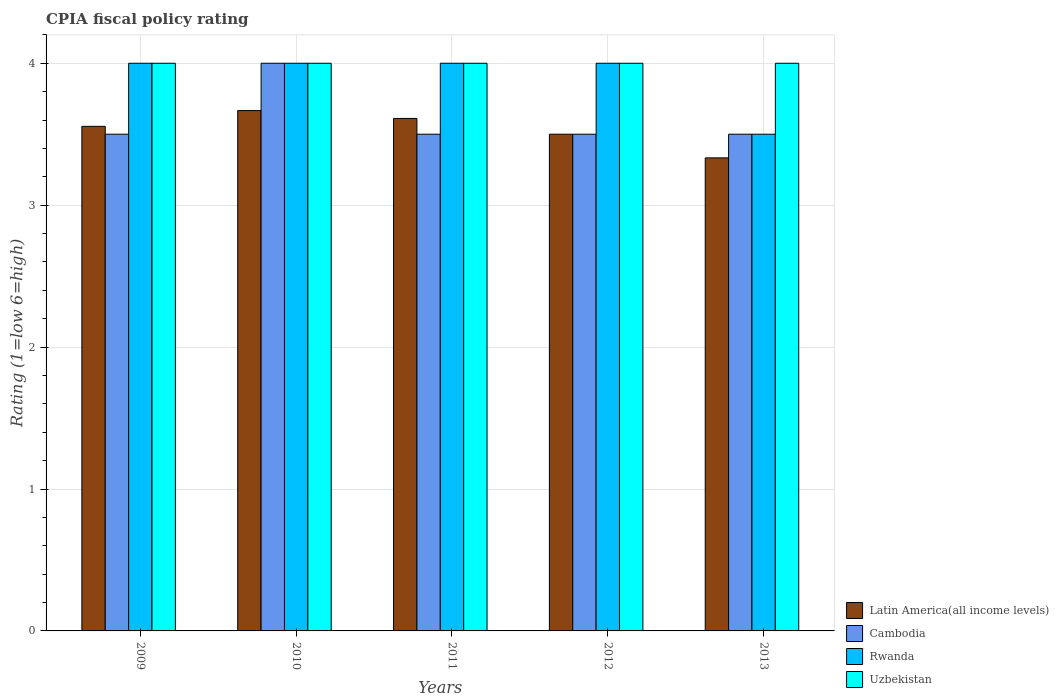Are the number of bars per tick equal to the number of legend labels?
Provide a succinct answer. Yes. Are the number of bars on each tick of the X-axis equal?
Ensure brevity in your answer.  Yes. How many bars are there on the 4th tick from the left?
Ensure brevity in your answer.  4. How many bars are there on the 2nd tick from the right?
Ensure brevity in your answer.  4. What is the CPIA rating in Cambodia in 2011?
Offer a terse response. 3.5. Across all years, what is the minimum CPIA rating in Rwanda?
Your answer should be compact. 3.5. In which year was the CPIA rating in Uzbekistan minimum?
Your answer should be very brief. 2009. What is the total CPIA rating in Latin America(all income levels) in the graph?
Provide a succinct answer. 17.67. What is the difference between the CPIA rating in Uzbekistan in 2010 and that in 2013?
Your answer should be very brief. 0. What is the difference between the CPIA rating in Uzbekistan in 2010 and the CPIA rating in Rwanda in 2012?
Your answer should be very brief. 0. What is the average CPIA rating in Rwanda per year?
Your answer should be compact. 3.9. In the year 2012, what is the difference between the CPIA rating in Latin America(all income levels) and CPIA rating in Rwanda?
Offer a terse response. -0.5. In how many years, is the CPIA rating in Uzbekistan greater than 4?
Provide a succinct answer. 0. What is the ratio of the CPIA rating in Rwanda in 2010 to that in 2013?
Provide a succinct answer. 1.14. Is the CPIA rating in Cambodia in 2010 less than that in 2011?
Your response must be concise. No. What is the difference between the highest and the second highest CPIA rating in Cambodia?
Give a very brief answer. 0.5. In how many years, is the CPIA rating in Rwanda greater than the average CPIA rating in Rwanda taken over all years?
Keep it short and to the point. 4. Is it the case that in every year, the sum of the CPIA rating in Latin America(all income levels) and CPIA rating in Uzbekistan is greater than the sum of CPIA rating in Cambodia and CPIA rating in Rwanda?
Your answer should be compact. No. What does the 3rd bar from the left in 2009 represents?
Ensure brevity in your answer.  Rwanda. What does the 1st bar from the right in 2012 represents?
Your answer should be very brief. Uzbekistan. How many years are there in the graph?
Your answer should be very brief. 5. Does the graph contain any zero values?
Ensure brevity in your answer.  No. Where does the legend appear in the graph?
Offer a very short reply. Bottom right. How many legend labels are there?
Provide a succinct answer. 4. How are the legend labels stacked?
Your response must be concise. Vertical. What is the title of the graph?
Your answer should be very brief. CPIA fiscal policy rating. Does "Europe(developing only)" appear as one of the legend labels in the graph?
Ensure brevity in your answer.  No. What is the label or title of the X-axis?
Keep it short and to the point. Years. What is the Rating (1=low 6=high) in Latin America(all income levels) in 2009?
Provide a succinct answer. 3.56. What is the Rating (1=low 6=high) in Rwanda in 2009?
Provide a short and direct response. 4. What is the Rating (1=low 6=high) of Latin America(all income levels) in 2010?
Your response must be concise. 3.67. What is the Rating (1=low 6=high) in Cambodia in 2010?
Keep it short and to the point. 4. What is the Rating (1=low 6=high) of Latin America(all income levels) in 2011?
Keep it short and to the point. 3.61. What is the Rating (1=low 6=high) of Cambodia in 2011?
Keep it short and to the point. 3.5. What is the Rating (1=low 6=high) in Rwanda in 2011?
Provide a succinct answer. 4. What is the Rating (1=low 6=high) in Uzbekistan in 2011?
Offer a very short reply. 4. What is the Rating (1=low 6=high) of Rwanda in 2012?
Make the answer very short. 4. What is the Rating (1=low 6=high) in Latin America(all income levels) in 2013?
Provide a succinct answer. 3.33. What is the Rating (1=low 6=high) in Rwanda in 2013?
Keep it short and to the point. 3.5. Across all years, what is the maximum Rating (1=low 6=high) of Latin America(all income levels)?
Ensure brevity in your answer.  3.67. Across all years, what is the maximum Rating (1=low 6=high) in Cambodia?
Offer a terse response. 4. Across all years, what is the maximum Rating (1=low 6=high) in Rwanda?
Ensure brevity in your answer.  4. Across all years, what is the maximum Rating (1=low 6=high) in Uzbekistan?
Keep it short and to the point. 4. Across all years, what is the minimum Rating (1=low 6=high) of Latin America(all income levels)?
Offer a terse response. 3.33. What is the total Rating (1=low 6=high) of Latin America(all income levels) in the graph?
Provide a short and direct response. 17.67. What is the total Rating (1=low 6=high) of Uzbekistan in the graph?
Give a very brief answer. 20. What is the difference between the Rating (1=low 6=high) in Latin America(all income levels) in 2009 and that in 2010?
Offer a terse response. -0.11. What is the difference between the Rating (1=low 6=high) of Cambodia in 2009 and that in 2010?
Provide a succinct answer. -0.5. What is the difference between the Rating (1=low 6=high) in Latin America(all income levels) in 2009 and that in 2011?
Your answer should be compact. -0.06. What is the difference between the Rating (1=low 6=high) in Rwanda in 2009 and that in 2011?
Your answer should be very brief. 0. What is the difference between the Rating (1=low 6=high) of Uzbekistan in 2009 and that in 2011?
Your response must be concise. 0. What is the difference between the Rating (1=low 6=high) in Latin America(all income levels) in 2009 and that in 2012?
Your answer should be compact. 0.06. What is the difference between the Rating (1=low 6=high) of Cambodia in 2009 and that in 2012?
Give a very brief answer. 0. What is the difference between the Rating (1=low 6=high) in Uzbekistan in 2009 and that in 2012?
Provide a succinct answer. 0. What is the difference between the Rating (1=low 6=high) of Latin America(all income levels) in 2009 and that in 2013?
Your answer should be compact. 0.22. What is the difference between the Rating (1=low 6=high) of Cambodia in 2009 and that in 2013?
Keep it short and to the point. 0. What is the difference between the Rating (1=low 6=high) of Rwanda in 2009 and that in 2013?
Provide a short and direct response. 0.5. What is the difference between the Rating (1=low 6=high) in Latin America(all income levels) in 2010 and that in 2011?
Offer a terse response. 0.06. What is the difference between the Rating (1=low 6=high) of Cambodia in 2010 and that in 2011?
Your answer should be compact. 0.5. What is the difference between the Rating (1=low 6=high) in Uzbekistan in 2010 and that in 2011?
Make the answer very short. 0. What is the difference between the Rating (1=low 6=high) in Latin America(all income levels) in 2010 and that in 2012?
Keep it short and to the point. 0.17. What is the difference between the Rating (1=low 6=high) in Rwanda in 2010 and that in 2012?
Give a very brief answer. 0. What is the difference between the Rating (1=low 6=high) in Latin America(all income levels) in 2010 and that in 2013?
Ensure brevity in your answer.  0.33. What is the difference between the Rating (1=low 6=high) of Cambodia in 2010 and that in 2013?
Offer a terse response. 0.5. What is the difference between the Rating (1=low 6=high) of Uzbekistan in 2010 and that in 2013?
Give a very brief answer. 0. What is the difference between the Rating (1=low 6=high) in Latin America(all income levels) in 2011 and that in 2013?
Offer a terse response. 0.28. What is the difference between the Rating (1=low 6=high) of Cambodia in 2011 and that in 2013?
Keep it short and to the point. 0. What is the difference between the Rating (1=low 6=high) of Latin America(all income levels) in 2009 and the Rating (1=low 6=high) of Cambodia in 2010?
Give a very brief answer. -0.44. What is the difference between the Rating (1=low 6=high) of Latin America(all income levels) in 2009 and the Rating (1=low 6=high) of Rwanda in 2010?
Ensure brevity in your answer.  -0.44. What is the difference between the Rating (1=low 6=high) in Latin America(all income levels) in 2009 and the Rating (1=low 6=high) in Uzbekistan in 2010?
Make the answer very short. -0.44. What is the difference between the Rating (1=low 6=high) of Cambodia in 2009 and the Rating (1=low 6=high) of Rwanda in 2010?
Provide a short and direct response. -0.5. What is the difference between the Rating (1=low 6=high) of Rwanda in 2009 and the Rating (1=low 6=high) of Uzbekistan in 2010?
Ensure brevity in your answer.  0. What is the difference between the Rating (1=low 6=high) in Latin America(all income levels) in 2009 and the Rating (1=low 6=high) in Cambodia in 2011?
Ensure brevity in your answer.  0.06. What is the difference between the Rating (1=low 6=high) of Latin America(all income levels) in 2009 and the Rating (1=low 6=high) of Rwanda in 2011?
Make the answer very short. -0.44. What is the difference between the Rating (1=low 6=high) in Latin America(all income levels) in 2009 and the Rating (1=low 6=high) in Uzbekistan in 2011?
Ensure brevity in your answer.  -0.44. What is the difference between the Rating (1=low 6=high) of Cambodia in 2009 and the Rating (1=low 6=high) of Rwanda in 2011?
Give a very brief answer. -0.5. What is the difference between the Rating (1=low 6=high) in Latin America(all income levels) in 2009 and the Rating (1=low 6=high) in Cambodia in 2012?
Provide a succinct answer. 0.06. What is the difference between the Rating (1=low 6=high) of Latin America(all income levels) in 2009 and the Rating (1=low 6=high) of Rwanda in 2012?
Offer a terse response. -0.44. What is the difference between the Rating (1=low 6=high) of Latin America(all income levels) in 2009 and the Rating (1=low 6=high) of Uzbekistan in 2012?
Your answer should be compact. -0.44. What is the difference between the Rating (1=low 6=high) of Cambodia in 2009 and the Rating (1=low 6=high) of Rwanda in 2012?
Make the answer very short. -0.5. What is the difference between the Rating (1=low 6=high) of Latin America(all income levels) in 2009 and the Rating (1=low 6=high) of Cambodia in 2013?
Ensure brevity in your answer.  0.06. What is the difference between the Rating (1=low 6=high) in Latin America(all income levels) in 2009 and the Rating (1=low 6=high) in Rwanda in 2013?
Your answer should be compact. 0.06. What is the difference between the Rating (1=low 6=high) in Latin America(all income levels) in 2009 and the Rating (1=low 6=high) in Uzbekistan in 2013?
Provide a succinct answer. -0.44. What is the difference between the Rating (1=low 6=high) of Latin America(all income levels) in 2010 and the Rating (1=low 6=high) of Cambodia in 2011?
Offer a terse response. 0.17. What is the difference between the Rating (1=low 6=high) in Latin America(all income levels) in 2010 and the Rating (1=low 6=high) in Rwanda in 2011?
Your response must be concise. -0.33. What is the difference between the Rating (1=low 6=high) of Cambodia in 2010 and the Rating (1=low 6=high) of Uzbekistan in 2011?
Keep it short and to the point. 0. What is the difference between the Rating (1=low 6=high) in Latin America(all income levels) in 2010 and the Rating (1=low 6=high) in Uzbekistan in 2012?
Keep it short and to the point. -0.33. What is the difference between the Rating (1=low 6=high) in Cambodia in 2010 and the Rating (1=low 6=high) in Uzbekistan in 2012?
Offer a very short reply. 0. What is the difference between the Rating (1=low 6=high) in Rwanda in 2010 and the Rating (1=low 6=high) in Uzbekistan in 2012?
Give a very brief answer. 0. What is the difference between the Rating (1=low 6=high) in Latin America(all income levels) in 2010 and the Rating (1=low 6=high) in Rwanda in 2013?
Ensure brevity in your answer.  0.17. What is the difference between the Rating (1=low 6=high) in Rwanda in 2010 and the Rating (1=low 6=high) in Uzbekistan in 2013?
Provide a short and direct response. 0. What is the difference between the Rating (1=low 6=high) in Latin America(all income levels) in 2011 and the Rating (1=low 6=high) in Rwanda in 2012?
Your response must be concise. -0.39. What is the difference between the Rating (1=low 6=high) in Latin America(all income levels) in 2011 and the Rating (1=low 6=high) in Uzbekistan in 2012?
Offer a terse response. -0.39. What is the difference between the Rating (1=low 6=high) in Rwanda in 2011 and the Rating (1=low 6=high) in Uzbekistan in 2012?
Provide a short and direct response. 0. What is the difference between the Rating (1=low 6=high) in Latin America(all income levels) in 2011 and the Rating (1=low 6=high) in Rwanda in 2013?
Provide a succinct answer. 0.11. What is the difference between the Rating (1=low 6=high) of Latin America(all income levels) in 2011 and the Rating (1=low 6=high) of Uzbekistan in 2013?
Your response must be concise. -0.39. What is the difference between the Rating (1=low 6=high) in Cambodia in 2011 and the Rating (1=low 6=high) in Uzbekistan in 2013?
Ensure brevity in your answer.  -0.5. What is the difference between the Rating (1=low 6=high) in Rwanda in 2011 and the Rating (1=low 6=high) in Uzbekistan in 2013?
Your answer should be compact. 0. What is the difference between the Rating (1=low 6=high) in Latin America(all income levels) in 2012 and the Rating (1=low 6=high) in Rwanda in 2013?
Your response must be concise. 0. What is the difference between the Rating (1=low 6=high) in Cambodia in 2012 and the Rating (1=low 6=high) in Uzbekistan in 2013?
Offer a terse response. -0.5. What is the average Rating (1=low 6=high) of Latin America(all income levels) per year?
Provide a succinct answer. 3.53. In the year 2009, what is the difference between the Rating (1=low 6=high) of Latin America(all income levels) and Rating (1=low 6=high) of Cambodia?
Give a very brief answer. 0.06. In the year 2009, what is the difference between the Rating (1=low 6=high) in Latin America(all income levels) and Rating (1=low 6=high) in Rwanda?
Your response must be concise. -0.44. In the year 2009, what is the difference between the Rating (1=low 6=high) in Latin America(all income levels) and Rating (1=low 6=high) in Uzbekistan?
Your answer should be very brief. -0.44. In the year 2009, what is the difference between the Rating (1=low 6=high) of Cambodia and Rating (1=low 6=high) of Rwanda?
Your answer should be very brief. -0.5. In the year 2009, what is the difference between the Rating (1=low 6=high) of Cambodia and Rating (1=low 6=high) of Uzbekistan?
Your response must be concise. -0.5. In the year 2010, what is the difference between the Rating (1=low 6=high) of Cambodia and Rating (1=low 6=high) of Uzbekistan?
Offer a terse response. 0. In the year 2010, what is the difference between the Rating (1=low 6=high) in Rwanda and Rating (1=low 6=high) in Uzbekistan?
Offer a very short reply. 0. In the year 2011, what is the difference between the Rating (1=low 6=high) in Latin America(all income levels) and Rating (1=low 6=high) in Rwanda?
Offer a very short reply. -0.39. In the year 2011, what is the difference between the Rating (1=low 6=high) in Latin America(all income levels) and Rating (1=low 6=high) in Uzbekistan?
Your response must be concise. -0.39. In the year 2011, what is the difference between the Rating (1=low 6=high) in Cambodia and Rating (1=low 6=high) in Rwanda?
Make the answer very short. -0.5. In the year 2013, what is the difference between the Rating (1=low 6=high) in Latin America(all income levels) and Rating (1=low 6=high) in Uzbekistan?
Ensure brevity in your answer.  -0.67. In the year 2013, what is the difference between the Rating (1=low 6=high) of Rwanda and Rating (1=low 6=high) of Uzbekistan?
Provide a short and direct response. -0.5. What is the ratio of the Rating (1=low 6=high) in Latin America(all income levels) in 2009 to that in 2010?
Provide a short and direct response. 0.97. What is the ratio of the Rating (1=low 6=high) in Uzbekistan in 2009 to that in 2010?
Ensure brevity in your answer.  1. What is the ratio of the Rating (1=low 6=high) of Latin America(all income levels) in 2009 to that in 2011?
Provide a short and direct response. 0.98. What is the ratio of the Rating (1=low 6=high) in Rwanda in 2009 to that in 2011?
Your response must be concise. 1. What is the ratio of the Rating (1=low 6=high) of Uzbekistan in 2009 to that in 2011?
Your response must be concise. 1. What is the ratio of the Rating (1=low 6=high) of Latin America(all income levels) in 2009 to that in 2012?
Make the answer very short. 1.02. What is the ratio of the Rating (1=low 6=high) in Rwanda in 2009 to that in 2012?
Provide a succinct answer. 1. What is the ratio of the Rating (1=low 6=high) in Latin America(all income levels) in 2009 to that in 2013?
Make the answer very short. 1.07. What is the ratio of the Rating (1=low 6=high) in Cambodia in 2009 to that in 2013?
Ensure brevity in your answer.  1. What is the ratio of the Rating (1=low 6=high) of Latin America(all income levels) in 2010 to that in 2011?
Offer a very short reply. 1.02. What is the ratio of the Rating (1=low 6=high) of Cambodia in 2010 to that in 2011?
Make the answer very short. 1.14. What is the ratio of the Rating (1=low 6=high) of Rwanda in 2010 to that in 2011?
Your answer should be compact. 1. What is the ratio of the Rating (1=low 6=high) of Latin America(all income levels) in 2010 to that in 2012?
Offer a terse response. 1.05. What is the ratio of the Rating (1=low 6=high) in Cambodia in 2010 to that in 2012?
Make the answer very short. 1.14. What is the ratio of the Rating (1=low 6=high) of Uzbekistan in 2010 to that in 2012?
Offer a very short reply. 1. What is the ratio of the Rating (1=low 6=high) of Cambodia in 2010 to that in 2013?
Offer a terse response. 1.14. What is the ratio of the Rating (1=low 6=high) in Latin America(all income levels) in 2011 to that in 2012?
Your answer should be very brief. 1.03. What is the ratio of the Rating (1=low 6=high) in Cambodia in 2011 to that in 2012?
Offer a very short reply. 1. What is the ratio of the Rating (1=low 6=high) of Rwanda in 2011 to that in 2012?
Make the answer very short. 1. What is the ratio of the Rating (1=low 6=high) of Latin America(all income levels) in 2011 to that in 2013?
Provide a succinct answer. 1.08. What is the difference between the highest and the second highest Rating (1=low 6=high) in Latin America(all income levels)?
Offer a terse response. 0.06. What is the difference between the highest and the second highest Rating (1=low 6=high) in Cambodia?
Give a very brief answer. 0.5. What is the difference between the highest and the lowest Rating (1=low 6=high) in Latin America(all income levels)?
Give a very brief answer. 0.33. What is the difference between the highest and the lowest Rating (1=low 6=high) in Cambodia?
Offer a very short reply. 0.5. What is the difference between the highest and the lowest Rating (1=low 6=high) of Uzbekistan?
Offer a very short reply. 0. 